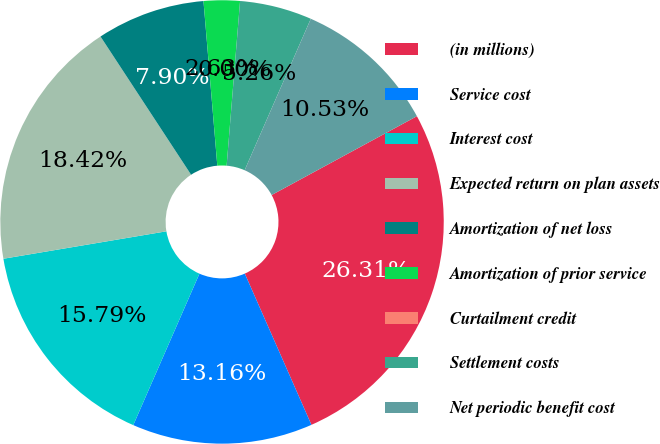Convert chart to OTSL. <chart><loc_0><loc_0><loc_500><loc_500><pie_chart><fcel>(in millions)<fcel>Service cost<fcel>Interest cost<fcel>Expected return on plan assets<fcel>Amortization of net loss<fcel>Amortization of prior service<fcel>Curtailment credit<fcel>Settlement costs<fcel>Net periodic benefit cost<nl><fcel>26.31%<fcel>13.16%<fcel>15.79%<fcel>18.42%<fcel>7.9%<fcel>2.63%<fcel>0.0%<fcel>5.26%<fcel>10.53%<nl></chart> 